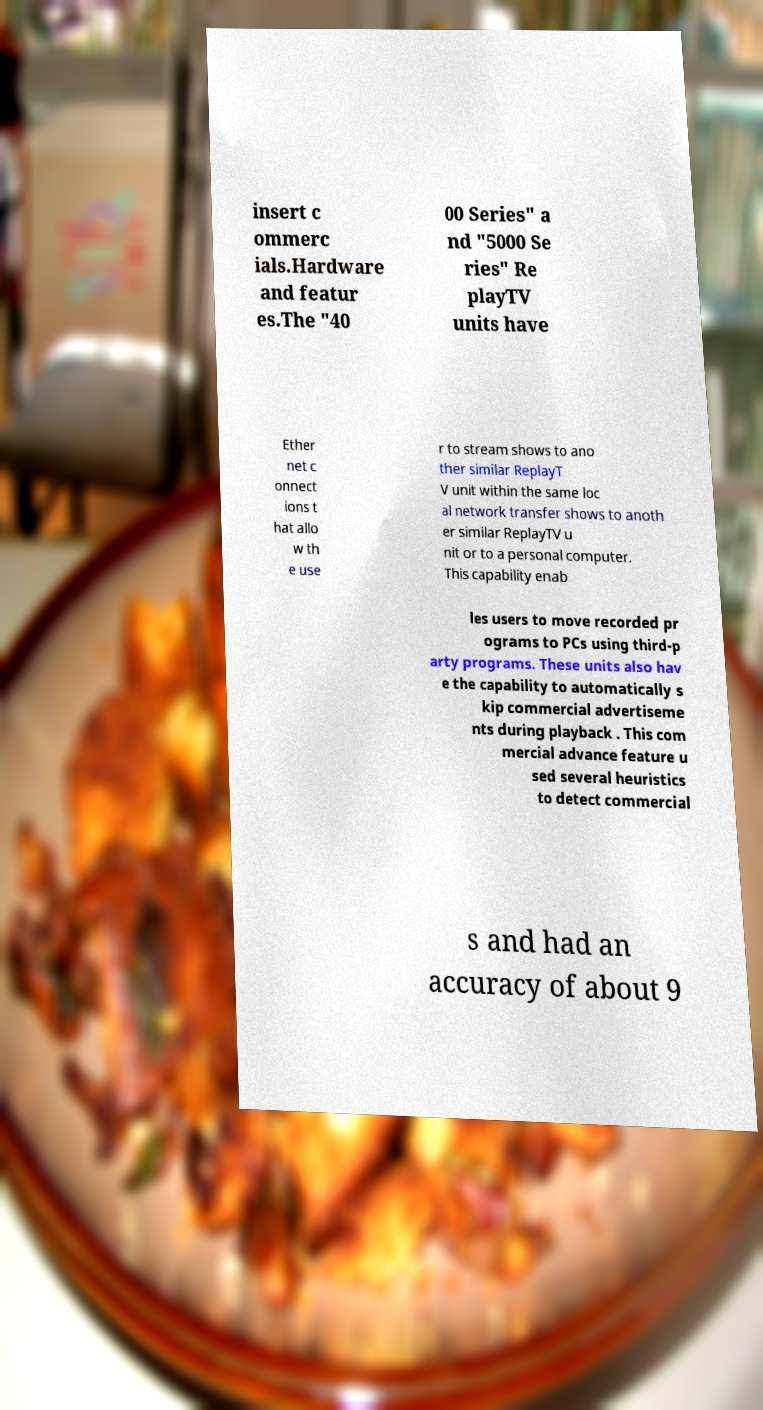Could you extract and type out the text from this image? insert c ommerc ials.Hardware and featur es.The "40 00 Series" a nd "5000 Se ries" Re playTV units have Ether net c onnect ions t hat allo w th e use r to stream shows to ano ther similar ReplayT V unit within the same loc al network transfer shows to anoth er similar ReplayTV u nit or to a personal computer. This capability enab les users to move recorded pr ograms to PCs using third-p arty programs. These units also hav e the capability to automatically s kip commercial advertiseme nts during playback . This com mercial advance feature u sed several heuristics to detect commercial s and had an accuracy of about 9 